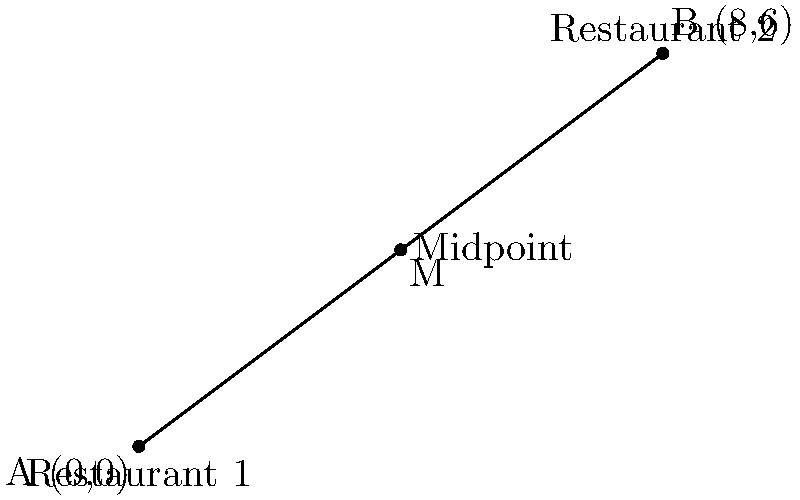As a hospitality manager overseeing restaurant operations in a new commercial development, you need to determine the optimal location for a shared supply depot between two restaurants. Restaurant 1 is located at coordinates (0,0), and Restaurant 2 is at (8,6). To minimize transportation costs, you decide to place the supply depot at the midpoint between the two restaurants. What are the coordinates of the supply depot? To find the midpoint of a line segment connecting two points, we use the midpoint formula:

$$ M_x = \frac{x_1 + x_2}{2}, \quad M_y = \frac{y_1 + y_2}{2} $$

Where $(x_1, y_1)$ are the coordinates of the first point and $(x_2, y_2)$ are the coordinates of the second point.

Given:
- Restaurant 1: $(x_1, y_1) = (0, 0)$
- Restaurant 2: $(x_2, y_2) = (8, 6)$

Step 1: Calculate the x-coordinate of the midpoint:
$$ M_x = \frac{x_1 + x_2}{2} = \frac{0 + 8}{2} = \frac{8}{2} = 4 $$

Step 2: Calculate the y-coordinate of the midpoint:
$$ M_y = \frac{y_1 + y_2}{2} = \frac{0 + 6}{2} = \frac{6}{2} = 3 $$

Therefore, the coordinates of the supply depot (midpoint) are (4, 3).
Answer: (4, 3) 